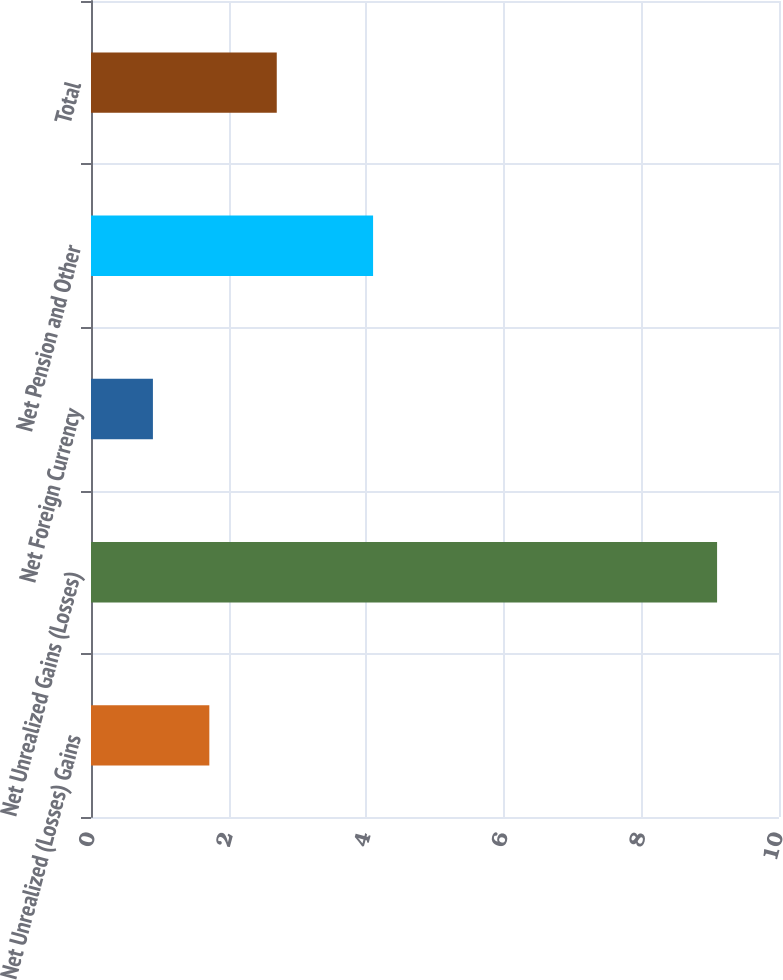<chart> <loc_0><loc_0><loc_500><loc_500><bar_chart><fcel>Net Unrealized (Losses) Gains<fcel>Net Unrealized Gains (Losses)<fcel>Net Foreign Currency<fcel>Net Pension and Other<fcel>Total<nl><fcel>1.72<fcel>9.1<fcel>0.9<fcel>4.1<fcel>2.7<nl></chart> 